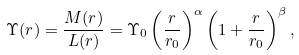<formula> <loc_0><loc_0><loc_500><loc_500>\Upsilon ( r ) = \frac { M ( r ) } { L ( r ) } = \Upsilon _ { 0 } \left ( \frac { r } { r _ { 0 } } \right ) ^ { \alpha } \left ( 1 + \frac { r } { r _ { 0 } } \right ) ^ { \beta } ,</formula> 